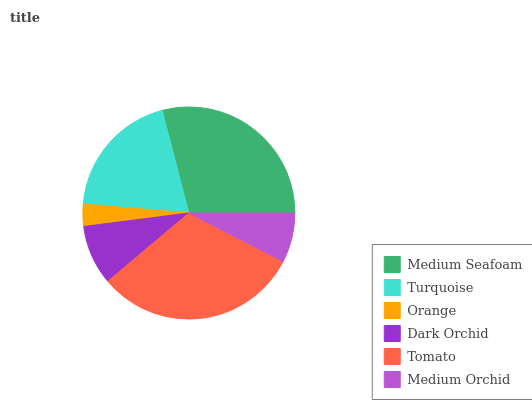Is Orange the minimum?
Answer yes or no. Yes. Is Tomato the maximum?
Answer yes or no. Yes. Is Turquoise the minimum?
Answer yes or no. No. Is Turquoise the maximum?
Answer yes or no. No. Is Medium Seafoam greater than Turquoise?
Answer yes or no. Yes. Is Turquoise less than Medium Seafoam?
Answer yes or no. Yes. Is Turquoise greater than Medium Seafoam?
Answer yes or no. No. Is Medium Seafoam less than Turquoise?
Answer yes or no. No. Is Turquoise the high median?
Answer yes or no. Yes. Is Dark Orchid the low median?
Answer yes or no. Yes. Is Orange the high median?
Answer yes or no. No. Is Medium Seafoam the low median?
Answer yes or no. No. 